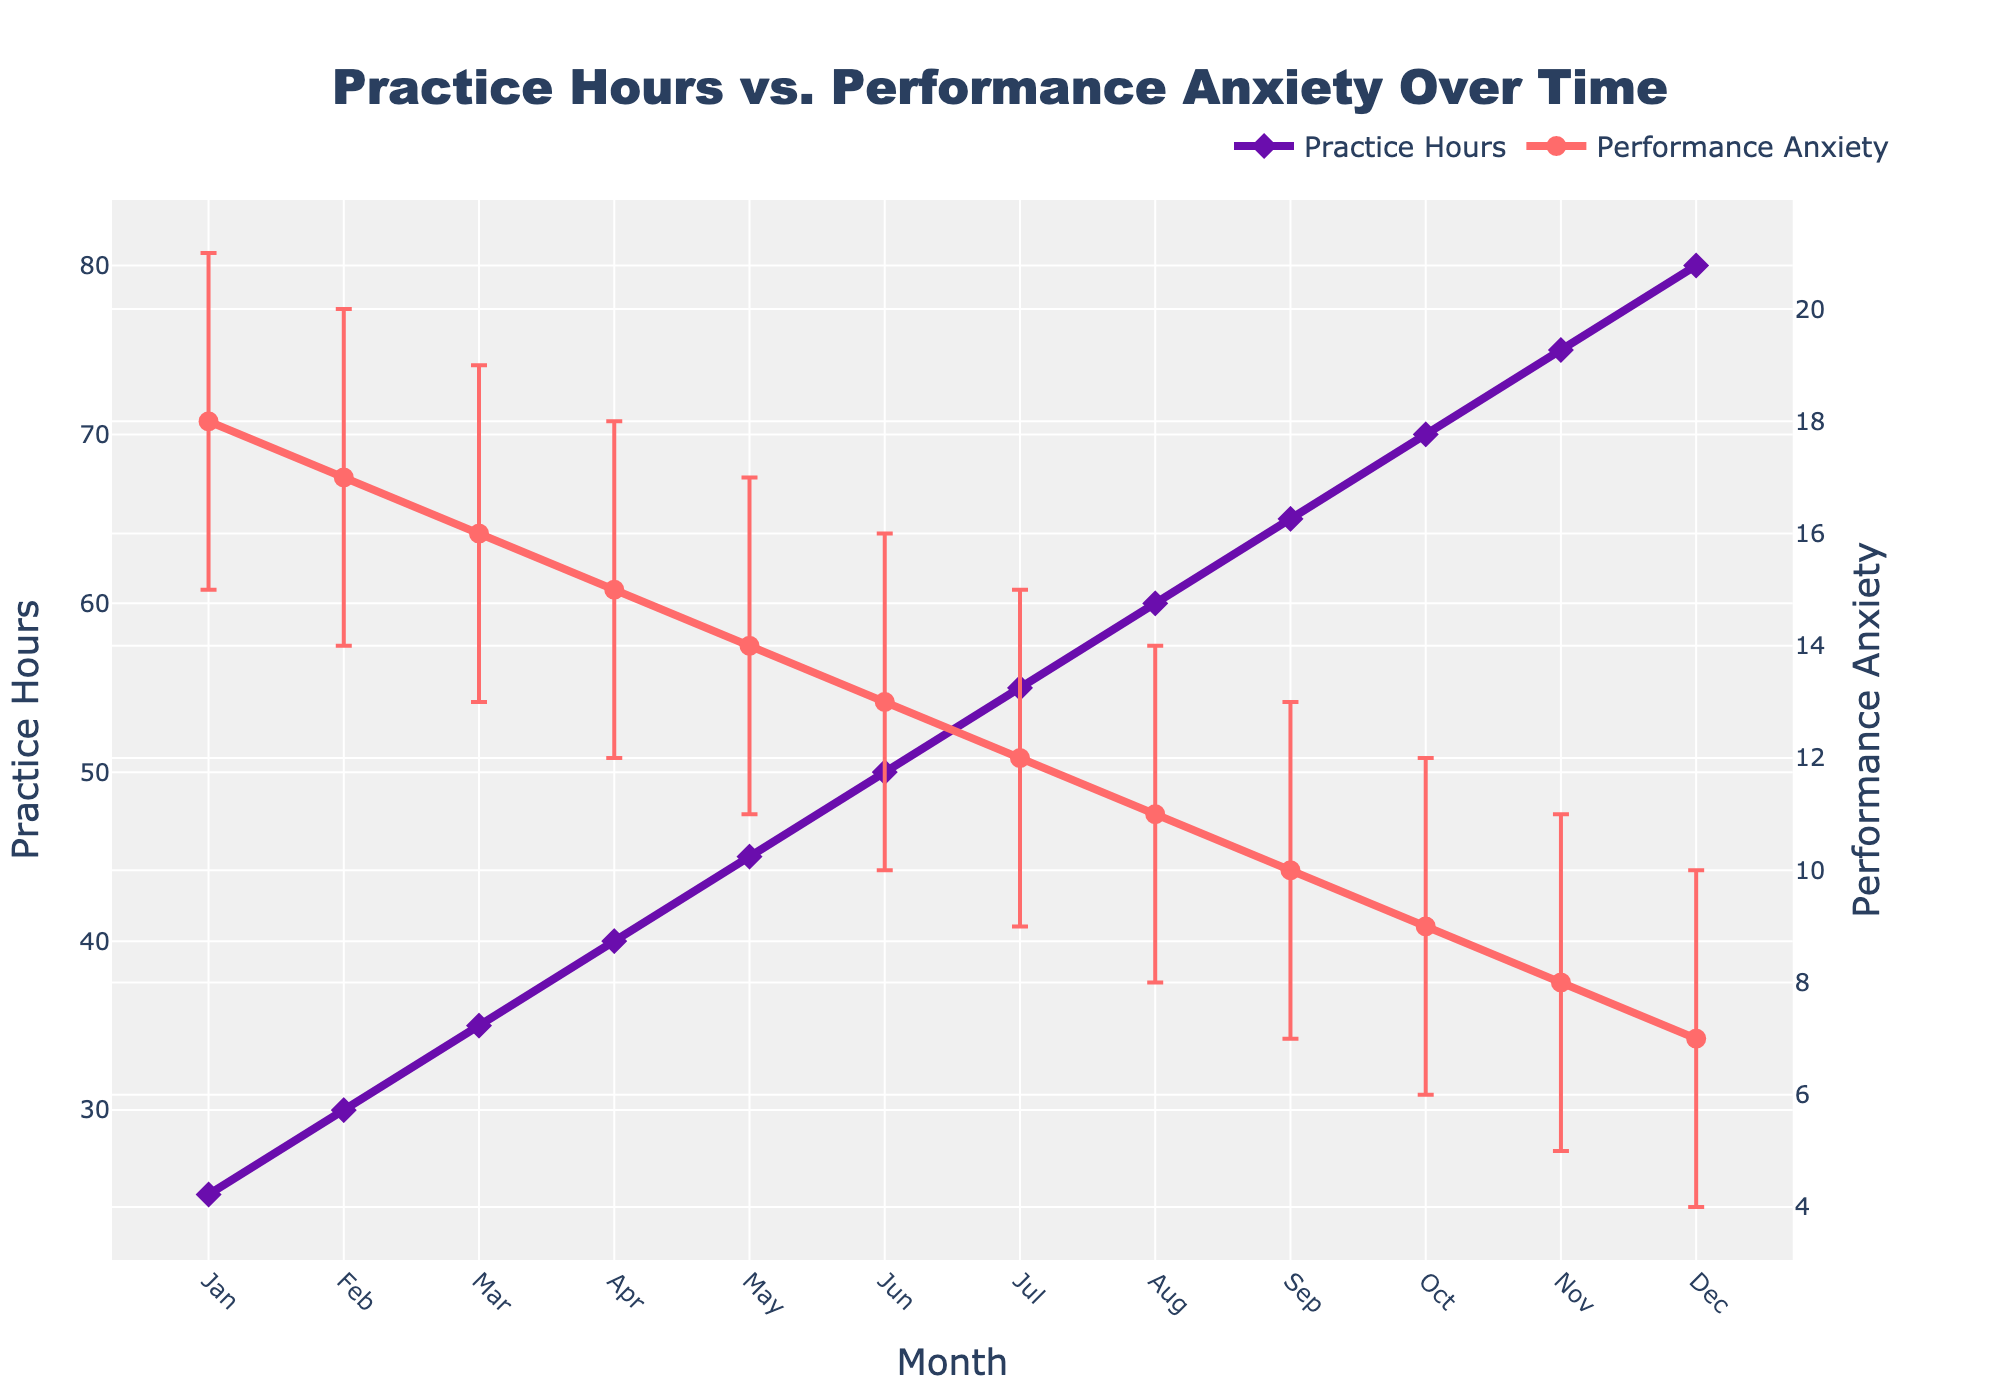How many months are represented in the plot? The X-axis shows the timeline divided by months. By counting the ticks on the X-axis, we can determine the number of months represented. Each month from January to December is included.
Answer: 12 What is the title of the plot? The plot's title is typically placed at the top of the figure and provides an overall description of the data represented. In this case, the title is "Practice Hours vs. Performance Anxiety Over Time".
Answer: Practice Hours vs. Performance Anxiety Over Time What is the trend in Practice Hours from January to December? The Practice Hours data is represented by the purple line with diamond markers. Observing the line's slope, we can see that the Practice Hours increase steadily from January to December.
Answer: Increasing Between which months does Performance Anxiety show the largest decrease? The Performance Anxiety data, shown as a red line with circle markers, should be examined for the steepest negative slope. The largest decrease occurs between November and December, where the value drops from 8 to 7.
Answer: November to December What are the upper and lower bounds of Performance Anxiety in July? The Performance Anxiety value for July is 12. The Upper Confidence Interval (CI) can be found by adding the upper error bar to the value, and the Lower CI by subtracting the lower error bar. For July: Upper CI = 12 + 3 = 15, and Lower CI = 12 - 3 = 9.
Answer: Upper CI: 15, Lower CI: 9 How do Practice Hours in February compare to those in August? Practice Hours are represented by the purple line. Referring to the Y-axis for Practice Hours, February has 30 hours and August has 60 hours, indicating that August has twice the practice hours compared to February.
Answer: More in August What is the average Performance Anxiety between June and August, inclusive? The values of Performance Anxiety from June to August are 13, 12, and 11, respectively. Summing these and dividing by the number of months gives the average: (13 + 12 + 11) / 3 = 12.
Answer: 12 By how many practice hours does the monthly practice increase on average from one month to the next? To find the average monthly increase, calculate the difference between consecutive months and then find the average. The total increase over the year is 80 - 25 = 55 hours. There are 11 intervals (Jan to Dec), so 55/11 = 5 hours increase on average per month.
Answer: 5 hours By how much did Performance Anxiety decrease from January to December? Subtract the Performance Anxiety value in December from the value in January. The decrease is from 18 to 7, which is a drop of 18 - 7 = 11.
Answer: 11 During which month is the Performance Anxiety's Confidence Interval the smallest? The width of the error bars shows the size of the Confidence Interval. By examining the plot, the smallest CI appears in May, where the CIs are between 11 and 17, having a width of 6.
Answer: May 